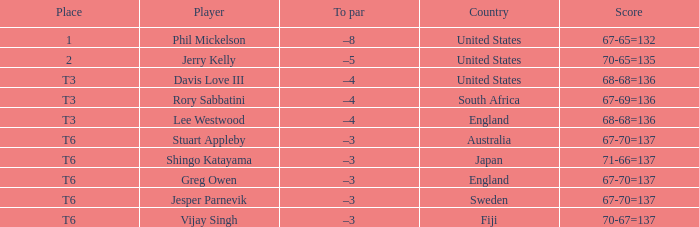Name the player for fiji Vijay Singh. 